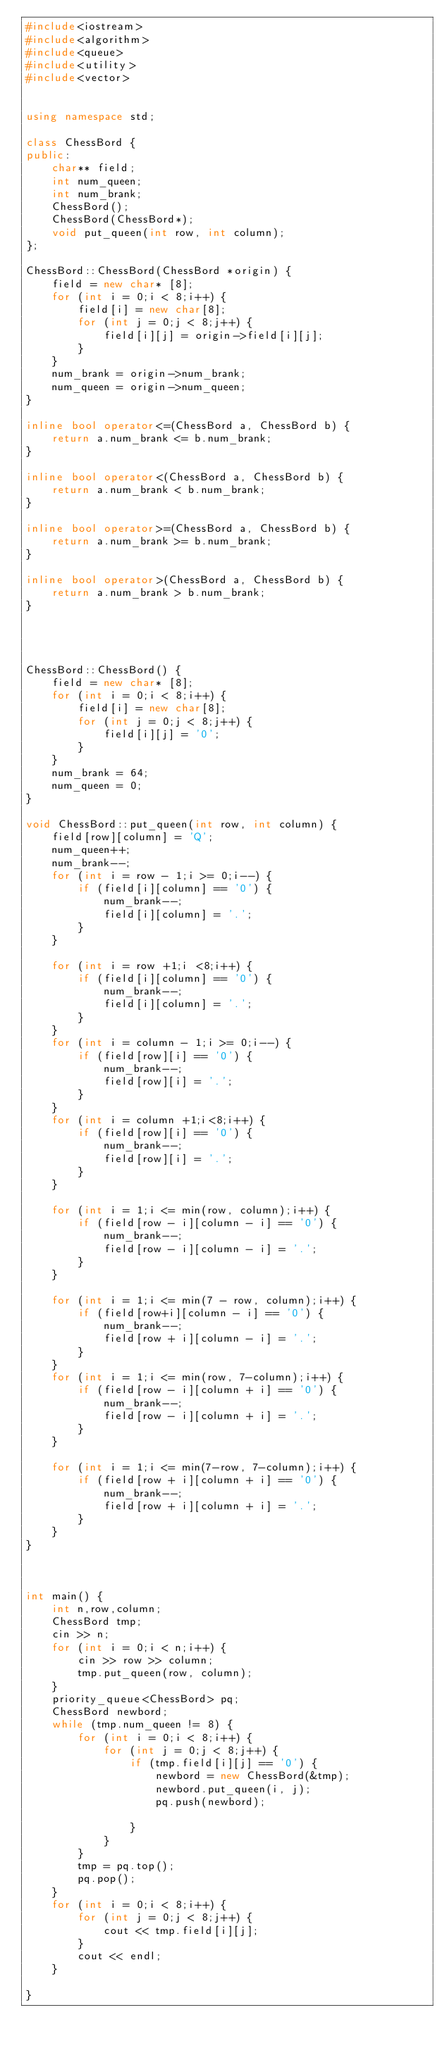Convert code to text. <code><loc_0><loc_0><loc_500><loc_500><_C++_>#include<iostream>
#include<algorithm>
#include<queue>
#include<utility>
#include<vector>


using namespace std;

class ChessBord {
public:
	char** field;
	int num_queen;
	int num_brank;
	ChessBord();
	ChessBord(ChessBord*);
	void put_queen(int row, int column);
};

ChessBord::ChessBord(ChessBord *origin) {
	field = new char* [8];
	for (int i = 0;i < 8;i++) {
		field[i] = new char[8];
		for (int j = 0;j < 8;j++) {
			field[i][j] = origin->field[i][j];
		}
	}
	num_brank = origin->num_brank;
	num_queen = origin->num_queen;
}
 
inline bool operator<=(ChessBord a, ChessBord b) {
	return a.num_brank <= b.num_brank;
}

inline bool operator<(ChessBord a, ChessBord b) {
	return a.num_brank < b.num_brank;
}

inline bool operator>=(ChessBord a, ChessBord b) {
	return a.num_brank >= b.num_brank;
}

inline bool operator>(ChessBord a, ChessBord b) {
	return a.num_brank > b.num_brank;
}




ChessBord::ChessBord() {
	field = new char* [8];
	for (int i = 0;i < 8;i++) {
		field[i] = new char[8];
		for (int j = 0;j < 8;j++) {
			field[i][j] = '0';
		}
	} 
	num_brank = 64;
	num_queen = 0;
}

void ChessBord::put_queen(int row, int column) {
	field[row][column] = 'Q';
	num_queen++;
	num_brank--;
	for (int i = row - 1;i >= 0;i--) {
		if (field[i][column] == '0') {
			num_brank--;
			field[i][column] = '.';
		}
	}

	for (int i = row +1;i <8;i++) {
		if (field[i][column] == '0') {
			num_brank--;
			field[i][column] = '.';
		}
	}
	for (int i = column - 1;i >= 0;i--) {
		if (field[row][i] == '0') {
			num_brank--;
			field[row][i] = '.';
		}
	}
	for (int i = column +1;i<8;i++) {
		if (field[row][i] == '0') {
			num_brank--;
			field[row][i] = '.';
		}
	}

	for (int i = 1;i <= min(row, column);i++) {
		if (field[row - i][column - i] == '0') {
			num_brank--;
			field[row - i][column - i] = '.';
		}
	}

	for (int i = 1;i <= min(7 - row, column);i++) {
		if (field[row+i][column - i] == '0') {
			num_brank--;
			field[row + i][column - i] = '.';
		}
	}
	for (int i = 1;i <= min(row, 7-column);i++) {
		if (field[row - i][column + i] == '0') {
			num_brank--;
			field[row - i][column + i] = '.';
		}
	}

	for (int i = 1;i <= min(7-row, 7-column);i++) {
		if (field[row + i][column + i] == '0') {
			num_brank--;
			field[row + i][column + i] = '.';
		}
	}
}



int main() {
	int n,row,column;
	ChessBord tmp;
	cin >> n;
	for (int i = 0;i < n;i++) {
		cin >> row >> column;
		tmp.put_queen(row, column);
	}
	priority_queue<ChessBord> pq;
	ChessBord newbord;
	while (tmp.num_queen != 8) {
		for (int i = 0;i < 8;i++) {
			for (int j = 0;j < 8;j++) {
				if (tmp.field[i][j] == '0') {
					newbord = new ChessBord(&tmp);
					newbord.put_queen(i, j);
					pq.push(newbord);
					
				}
			}
		}
		tmp = pq.top();
		pq.pop();
	}
	for (int i = 0;i < 8;i++) {
		for (int j = 0;j < 8;j++) {
			cout << tmp.field[i][j];
		}
		cout << endl;
	}
	
}


</code> 